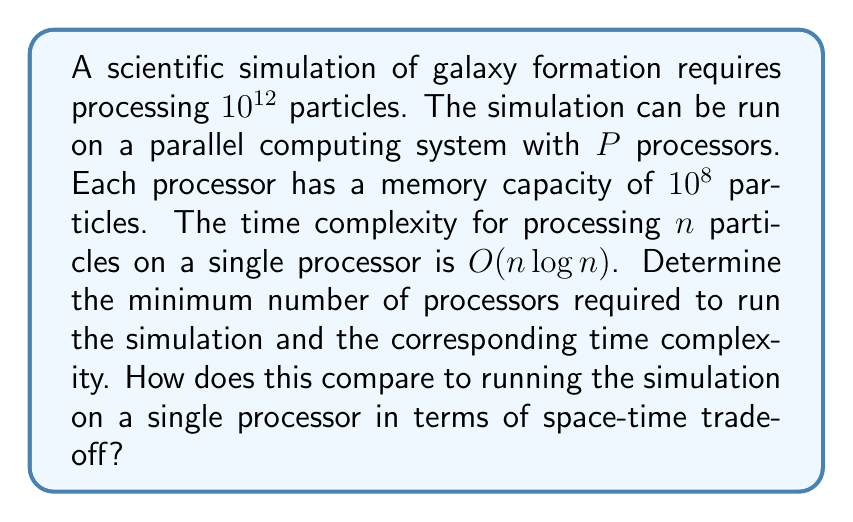Can you answer this question? To solve this problem, we need to consider both the space (memory) constraints and the time complexity of the algorithm. Let's approach this step-by-step:

1. Space constraint:
   Each processor can handle $10^8$ particles. To process $10^{12}$ particles, we need:
   
   $$P = \frac{10^{12}}{10^8} = 10^4 = 10,000\text{ processors}$$

2. Time complexity for parallel processing:
   With $P$ processors, each processor will handle $\frac{n}{P}$ particles, where $n = 10^{12}$.
   
   Time complexity for each processor: $O(\frac{n}{P} \log \frac{n}{P})$
   
   Substituting the values:
   $$O(\frac{10^{12}}{10^4} \log \frac{10^{12}}{10^4}) = O(10^8 \log 10^8) = O(8 \times 10^8)$$

3. Time complexity for single processor:
   $$O(n \log n) = O(10^{12} \log 10^{12}) = O(12 \times 10^{12})$$

4. Space-time trade-off:
   - Parallel processing:
     - Space: Requires 10,000 times more memory (distributed across processors)
     - Time: Reduces time complexity by a factor of 15,000 (from $12 \times 10^{12}$ to $8 \times 10^8$)

   This demonstrates a significant reduction in processing time at the cost of increased total memory usage and hardware requirements.
Answer: Minimum number of processors: 10,000
Time complexity with parallel processing: $O(8 \times 10^8)$
Comparison to single processor:
- Space usage: 10,000 times more
- Time reduction: Factor of 15,000 